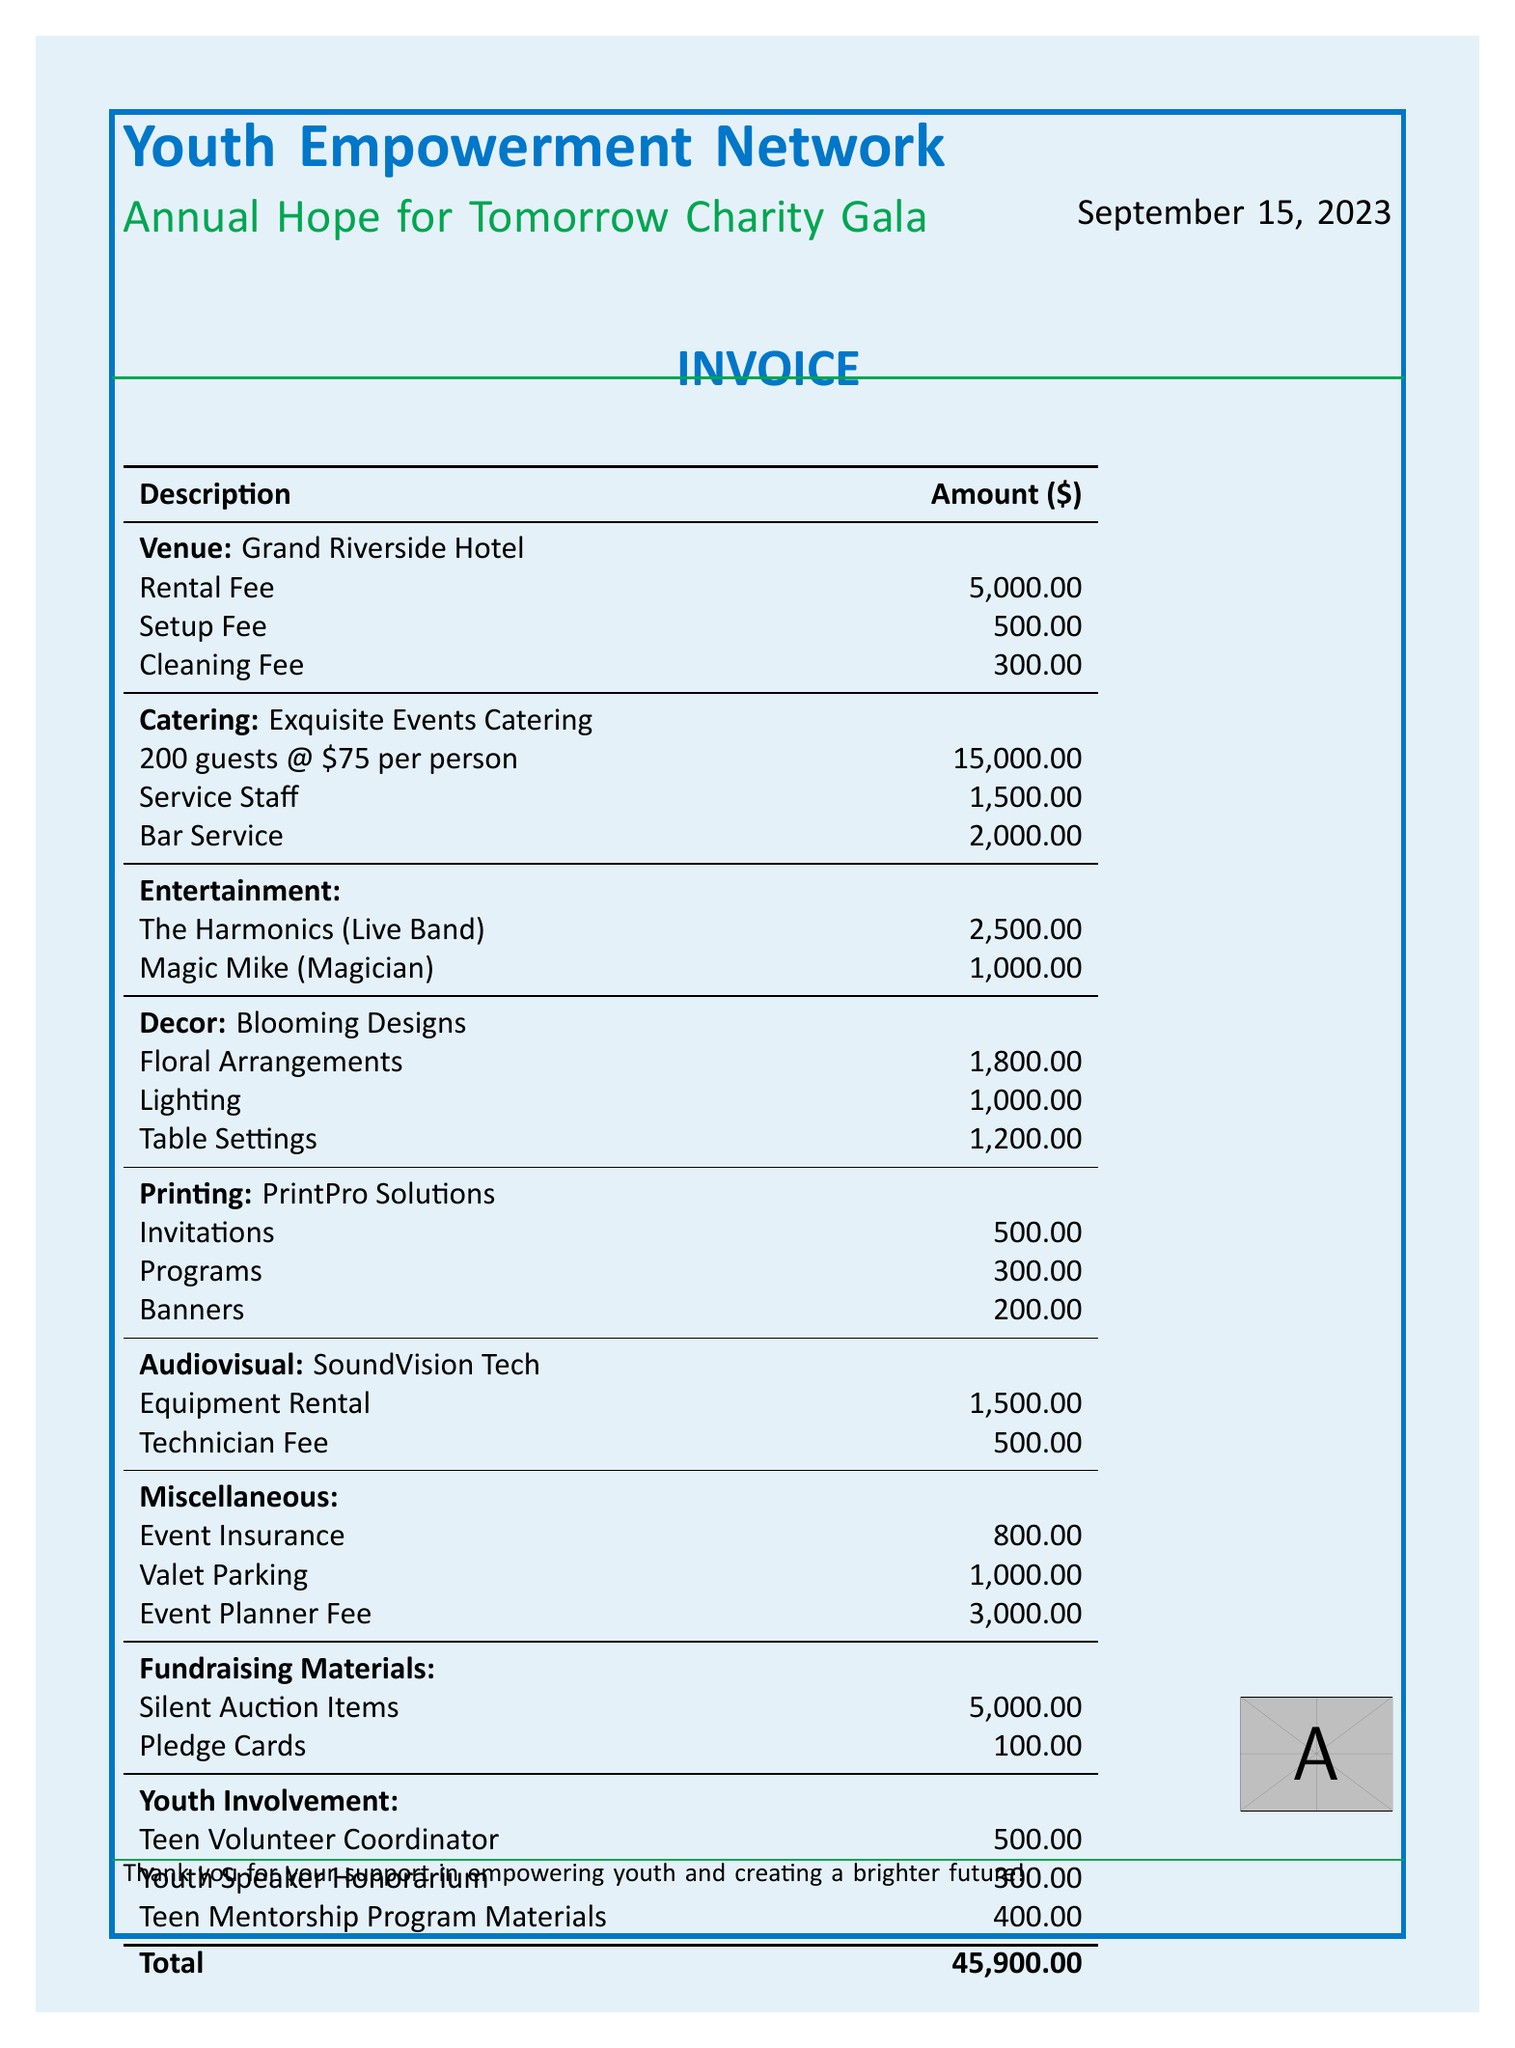What is the name of the venue? The venue for the event is listed as "Grand Riverside Hotel".
Answer: Grand Riverside Hotel What is the catering per person cost? The cost per person for catering is provided as $75.
Answer: 75 How many guests were expected at the event? The invoice states that there will be 200 guests attending the event.
Answer: 200 What is the total fee for The Harmonics? The fee specified for The Harmonics, the live band, is $2,500.
Answer: 2500 What is the total cost for decor? The decor costs are summarized as: floral arrangements $1,800 + lighting $1,000 + table settings $1,200, which totals $4,000.
Answer: 4000 What is the total amount for entertainment? The total entertainment costs are combined from both entertainers: The Harmonics $2,500 + Magic Mike $1,000, making it $3,500 in total.
Answer: 3500 What are the total miscellaneous costs? Miscellaneous costs include event insurance $800 + valet parking $1,000 + event planner fee $3,000, totaling $4,800.
Answer: 4800 How much is the total invoice amount? The total amount calculated for the invoice, including all categories, is $45,900.
Answer: 45900 What is the provider for audiovisual services? The provider for audiovisual services is identified as "SoundVision Tech".
Answer: SoundVision Tech 